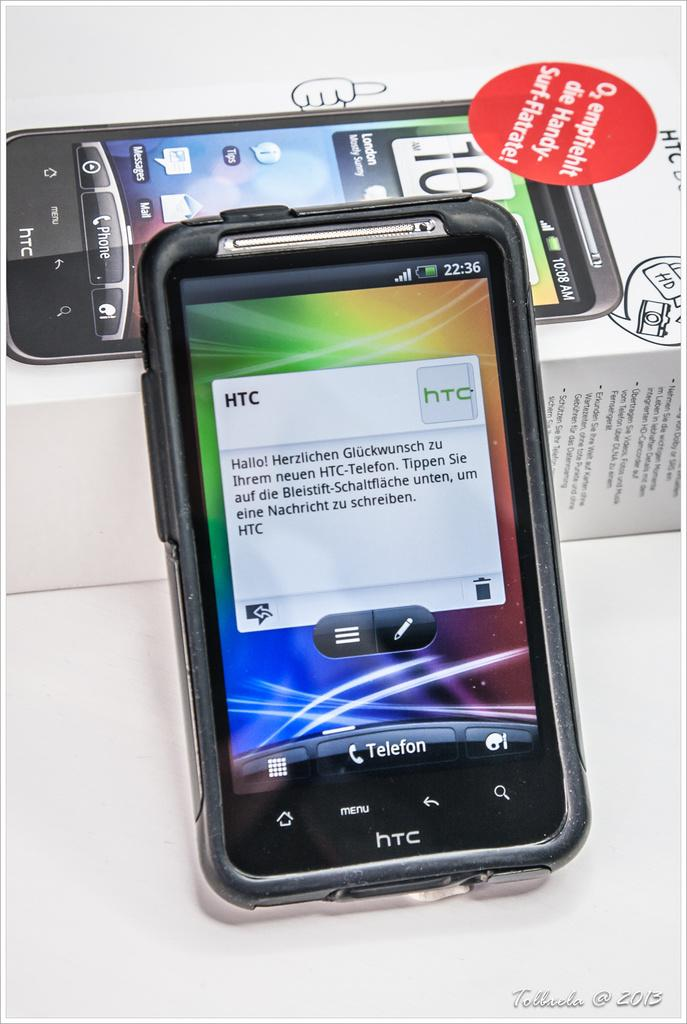<image>
Describe the image concisely. HTC smartphone with time displayed as 22.36 next to original packaging. 